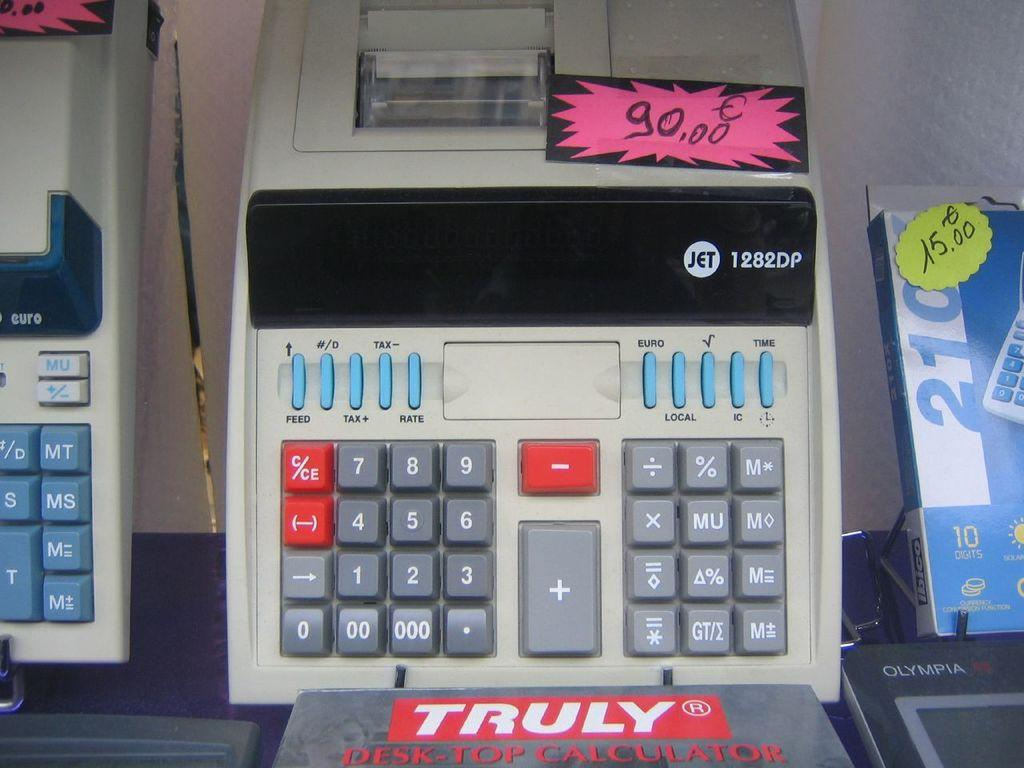<image>
Relay a brief, clear account of the picture shown. An old adding machine is being sold for 90.00 Euros. 